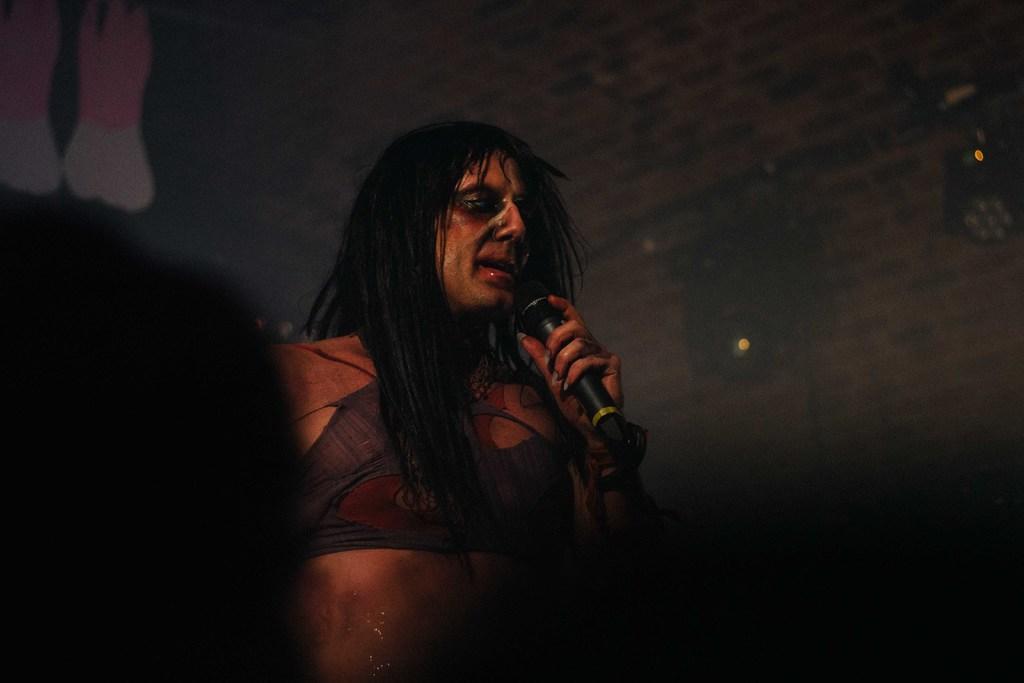Describe this image in one or two sentences. In the center of the image there is a man standing in a costume. He is holding a mic in his hand. 